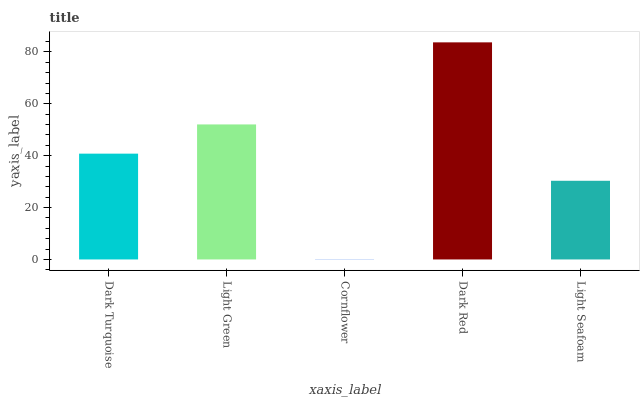Is Light Green the minimum?
Answer yes or no. No. Is Light Green the maximum?
Answer yes or no. No. Is Light Green greater than Dark Turquoise?
Answer yes or no. Yes. Is Dark Turquoise less than Light Green?
Answer yes or no. Yes. Is Dark Turquoise greater than Light Green?
Answer yes or no. No. Is Light Green less than Dark Turquoise?
Answer yes or no. No. Is Dark Turquoise the high median?
Answer yes or no. Yes. Is Dark Turquoise the low median?
Answer yes or no. Yes. Is Light Green the high median?
Answer yes or no. No. Is Dark Red the low median?
Answer yes or no. No. 